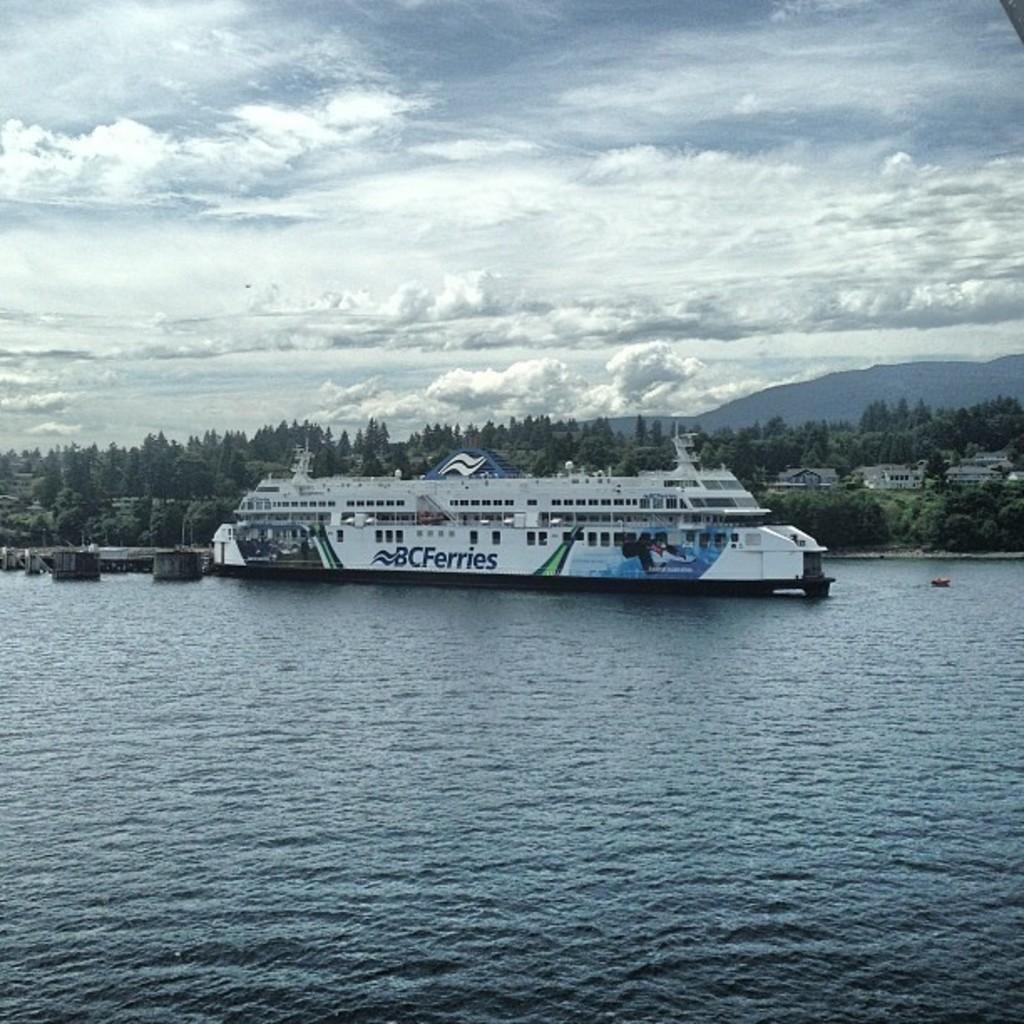How would you summarize this image in a sentence or two? There is a ship on the water. On the ship there are windows and something is written. In the background there are trees, buildings, hills and sky with clouds. 